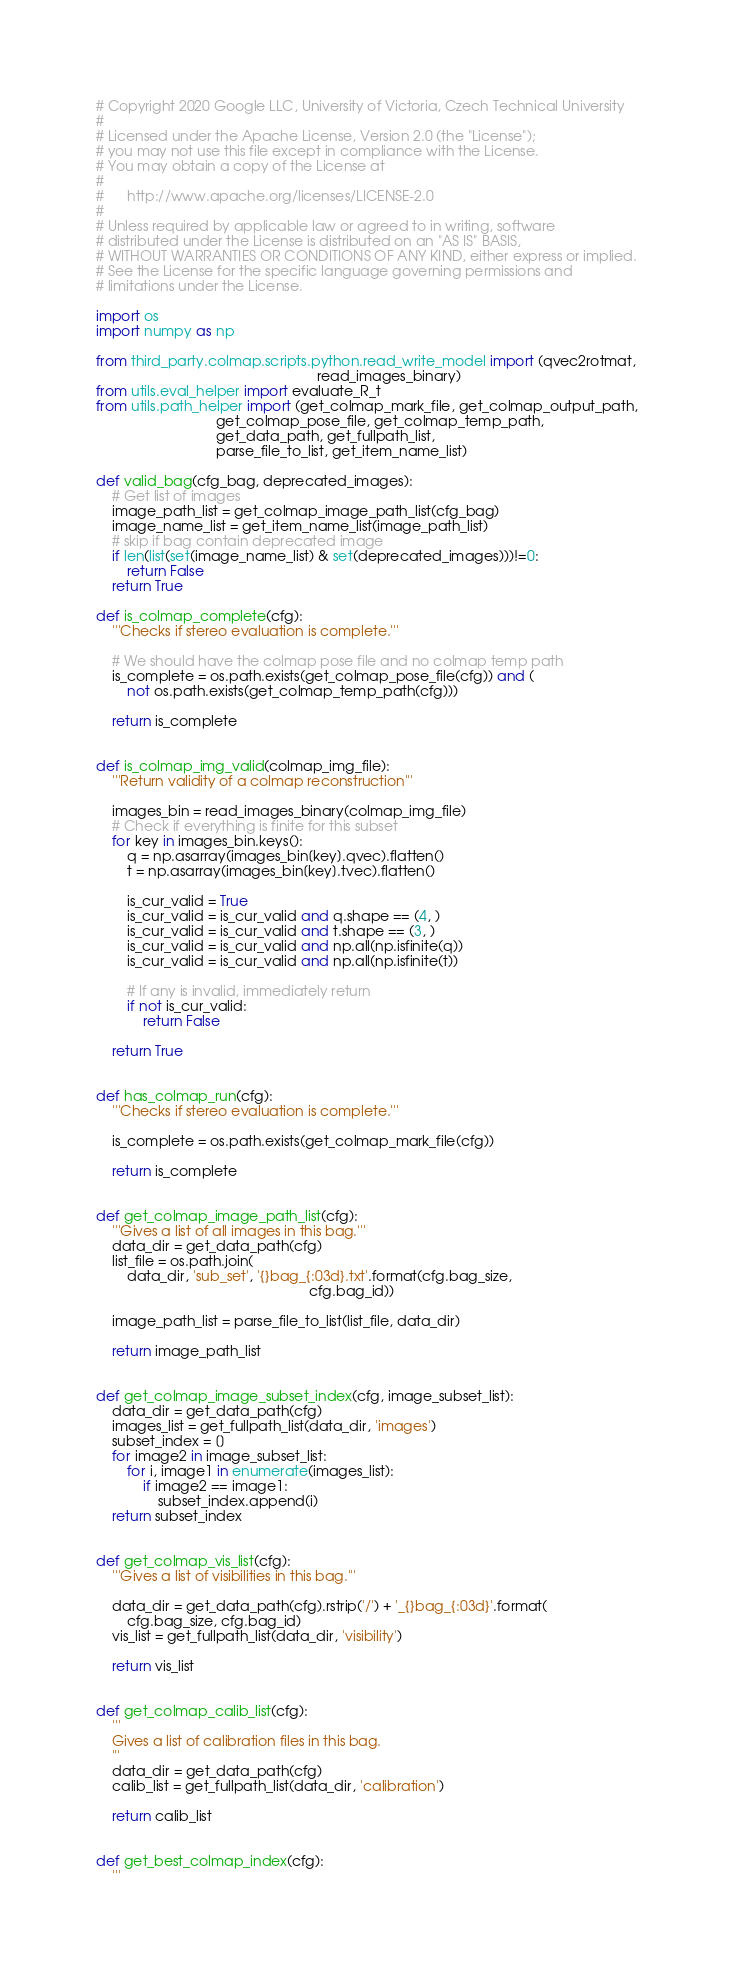Convert code to text. <code><loc_0><loc_0><loc_500><loc_500><_Python_># Copyright 2020 Google LLC, University of Victoria, Czech Technical University
#
# Licensed under the Apache License, Version 2.0 (the "License");
# you may not use this file except in compliance with the License.
# You may obtain a copy of the License at
#
#      http://www.apache.org/licenses/LICENSE-2.0
#
# Unless required by applicable law or agreed to in writing, software
# distributed under the License is distributed on an "AS IS" BASIS,
# WITHOUT WARRANTIES OR CONDITIONS OF ANY KIND, either express or implied.
# See the License for the specific language governing permissions and
# limitations under the License.

import os
import numpy as np

from third_party.colmap.scripts.python.read_write_model import (qvec2rotmat,
                                                         read_images_binary)
from utils.eval_helper import evaluate_R_t
from utils.path_helper import (get_colmap_mark_file, get_colmap_output_path,
                               get_colmap_pose_file, get_colmap_temp_path,
                               get_data_path, get_fullpath_list,
                               parse_file_to_list, get_item_name_list)

def valid_bag(cfg_bag, deprecated_images):
    # Get list of images
    image_path_list = get_colmap_image_path_list(cfg_bag)
    image_name_list = get_item_name_list(image_path_list)
    # skip if bag contain deprecated image
    if len(list(set(image_name_list) & set(deprecated_images)))!=0:
        return False
    return True 

def is_colmap_complete(cfg):
    '''Checks if stereo evaluation is complete.'''

    # We should have the colmap pose file and no colmap temp path
    is_complete = os.path.exists(get_colmap_pose_file(cfg)) and (
        not os.path.exists(get_colmap_temp_path(cfg)))

    return is_complete


def is_colmap_img_valid(colmap_img_file):
    '''Return validity of a colmap reconstruction'''

    images_bin = read_images_binary(colmap_img_file)
    # Check if everything is finite for this subset
    for key in images_bin.keys():
        q = np.asarray(images_bin[key].qvec).flatten()
        t = np.asarray(images_bin[key].tvec).flatten()

        is_cur_valid = True
        is_cur_valid = is_cur_valid and q.shape == (4, )
        is_cur_valid = is_cur_valid and t.shape == (3, )
        is_cur_valid = is_cur_valid and np.all(np.isfinite(q))
        is_cur_valid = is_cur_valid and np.all(np.isfinite(t))

        # If any is invalid, immediately return
        if not is_cur_valid:
            return False

    return True


def has_colmap_run(cfg):
    '''Checks if stereo evaluation is complete.'''

    is_complete = os.path.exists(get_colmap_mark_file(cfg))

    return is_complete


def get_colmap_image_path_list(cfg):
    '''Gives a list of all images in this bag.'''
    data_dir = get_data_path(cfg)
    list_file = os.path.join(
        data_dir, 'sub_set', '{}bag_{:03d}.txt'.format(cfg.bag_size,
                                                       cfg.bag_id))

    image_path_list = parse_file_to_list(list_file, data_dir)

    return image_path_list


def get_colmap_image_subset_index(cfg, image_subset_list):
    data_dir = get_data_path(cfg)
    images_list = get_fullpath_list(data_dir, 'images')
    subset_index = []
    for image2 in image_subset_list:
        for i, image1 in enumerate(images_list):
            if image2 == image1:
                subset_index.append(i)
    return subset_index


def get_colmap_vis_list(cfg):
    '''Gives a list of visibilities in this bag.'''

    data_dir = get_data_path(cfg).rstrip('/') + '_{}bag_{:03d}'.format(
        cfg.bag_size, cfg.bag_id)
    vis_list = get_fullpath_list(data_dir, 'visibility')

    return vis_list


def get_colmap_calib_list(cfg):
    '''
    Gives a list of calibration files in this bag.
    '''
    data_dir = get_data_path(cfg)
    calib_list = get_fullpath_list(data_dir, 'calibration')

    return calib_list


def get_best_colmap_index(cfg):
    '''</code> 